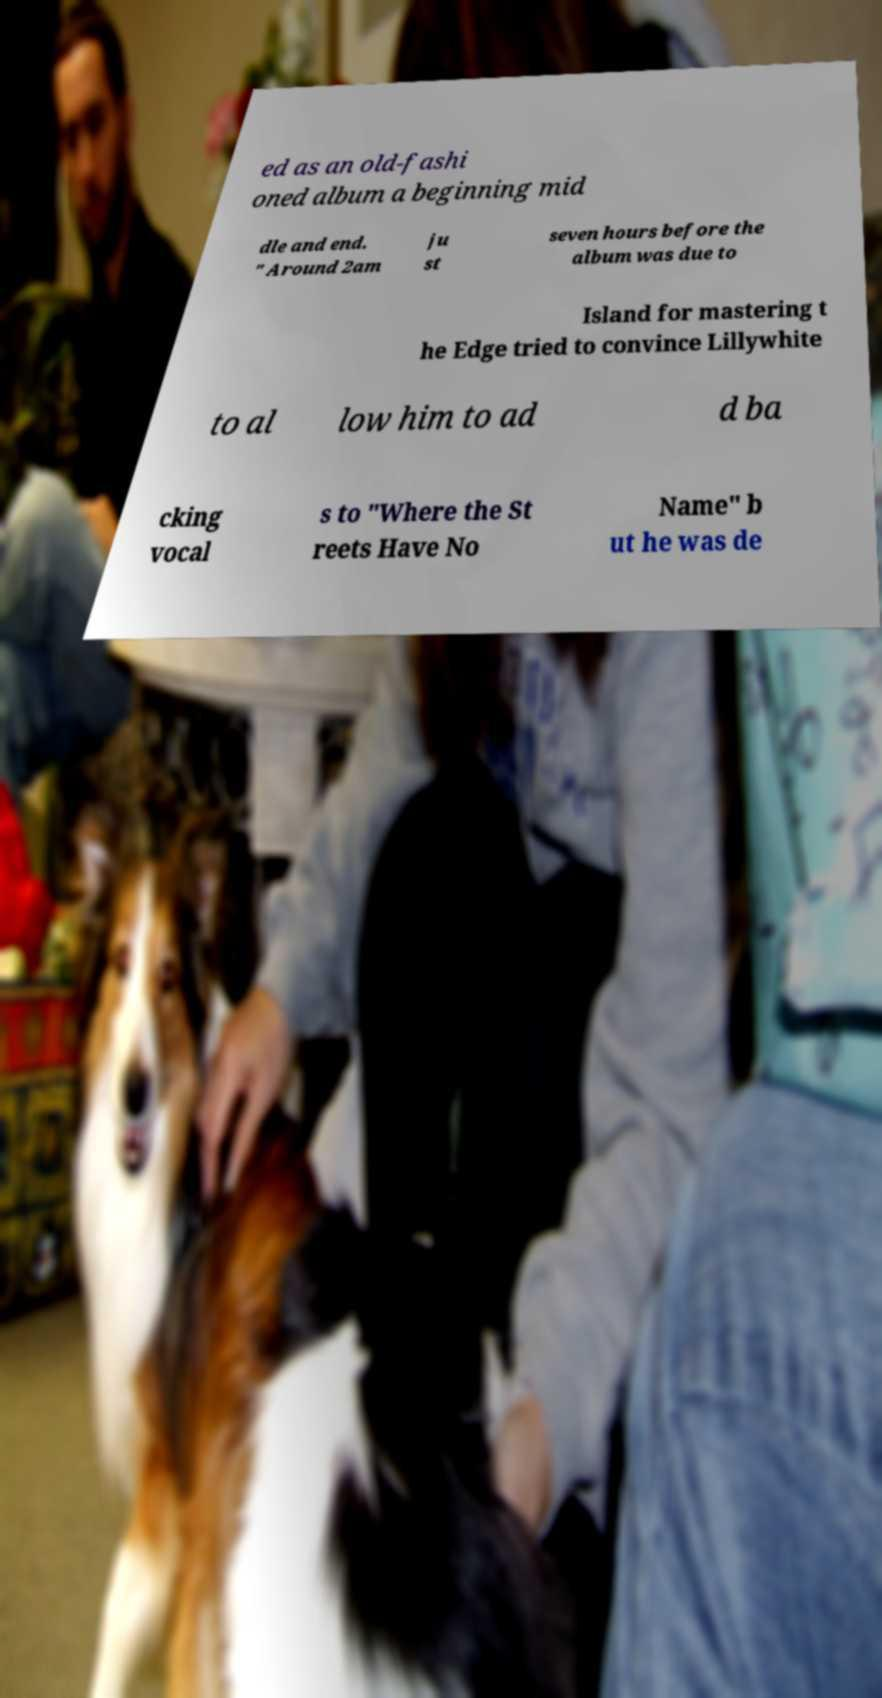There's text embedded in this image that I need extracted. Can you transcribe it verbatim? ed as an old-fashi oned album a beginning mid dle and end. " Around 2am ju st seven hours before the album was due to Island for mastering t he Edge tried to convince Lillywhite to al low him to ad d ba cking vocal s to "Where the St reets Have No Name" b ut he was de 